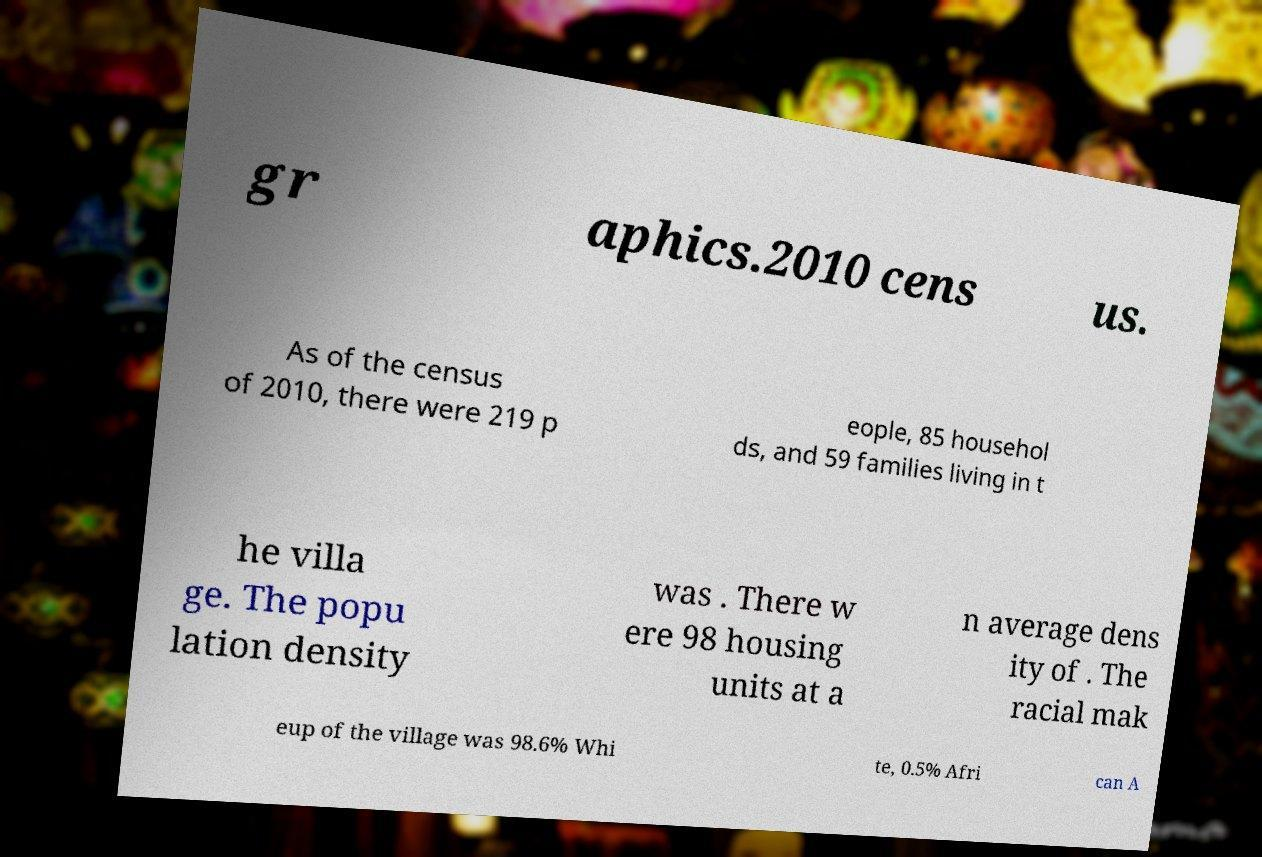Could you assist in decoding the text presented in this image and type it out clearly? gr aphics.2010 cens us. As of the census of 2010, there were 219 p eople, 85 househol ds, and 59 families living in t he villa ge. The popu lation density was . There w ere 98 housing units at a n average dens ity of . The racial mak eup of the village was 98.6% Whi te, 0.5% Afri can A 